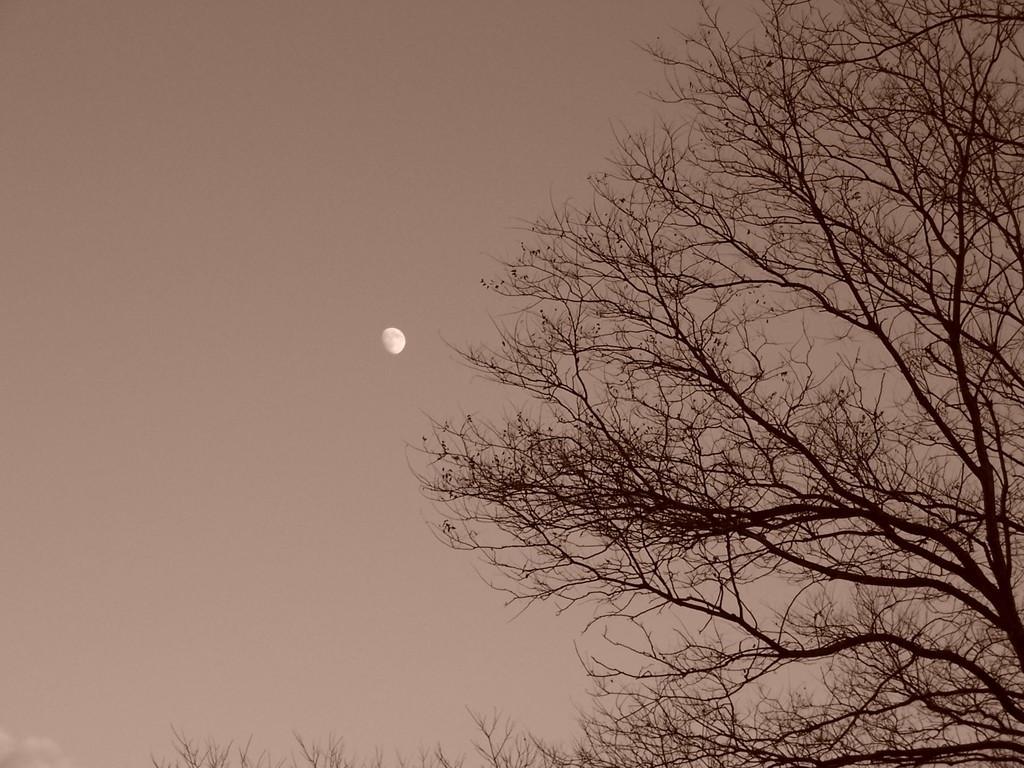Please provide a concise description of this image. Right side of image there are few trees. Background there is sky having moon. 